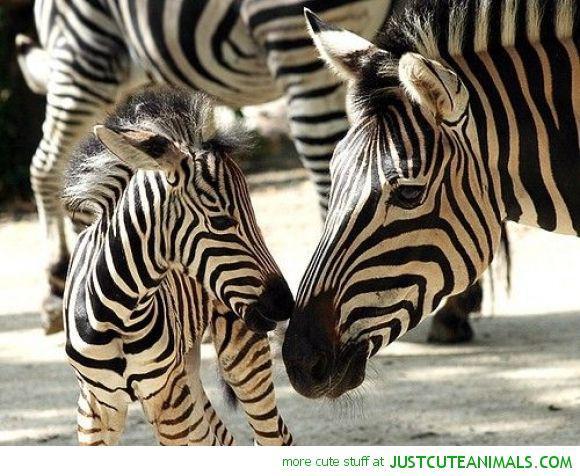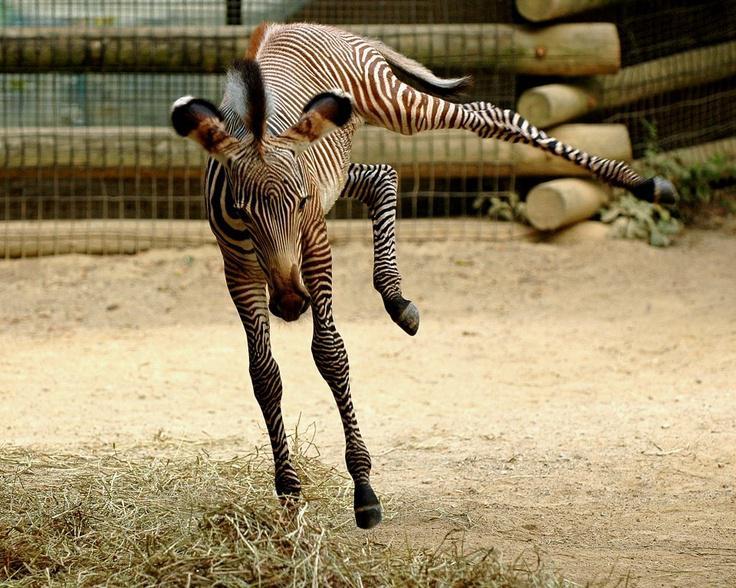The first image is the image on the left, the second image is the image on the right. Considering the images on both sides, is "One image shows two zebras face-to-face and standing upright with their heads crossed." valid? Answer yes or no. No. The first image is the image on the left, the second image is the image on the right. For the images displayed, is the sentence "In at least one image there is a mother and calf zebra touching noses." factually correct? Answer yes or no. Yes. 